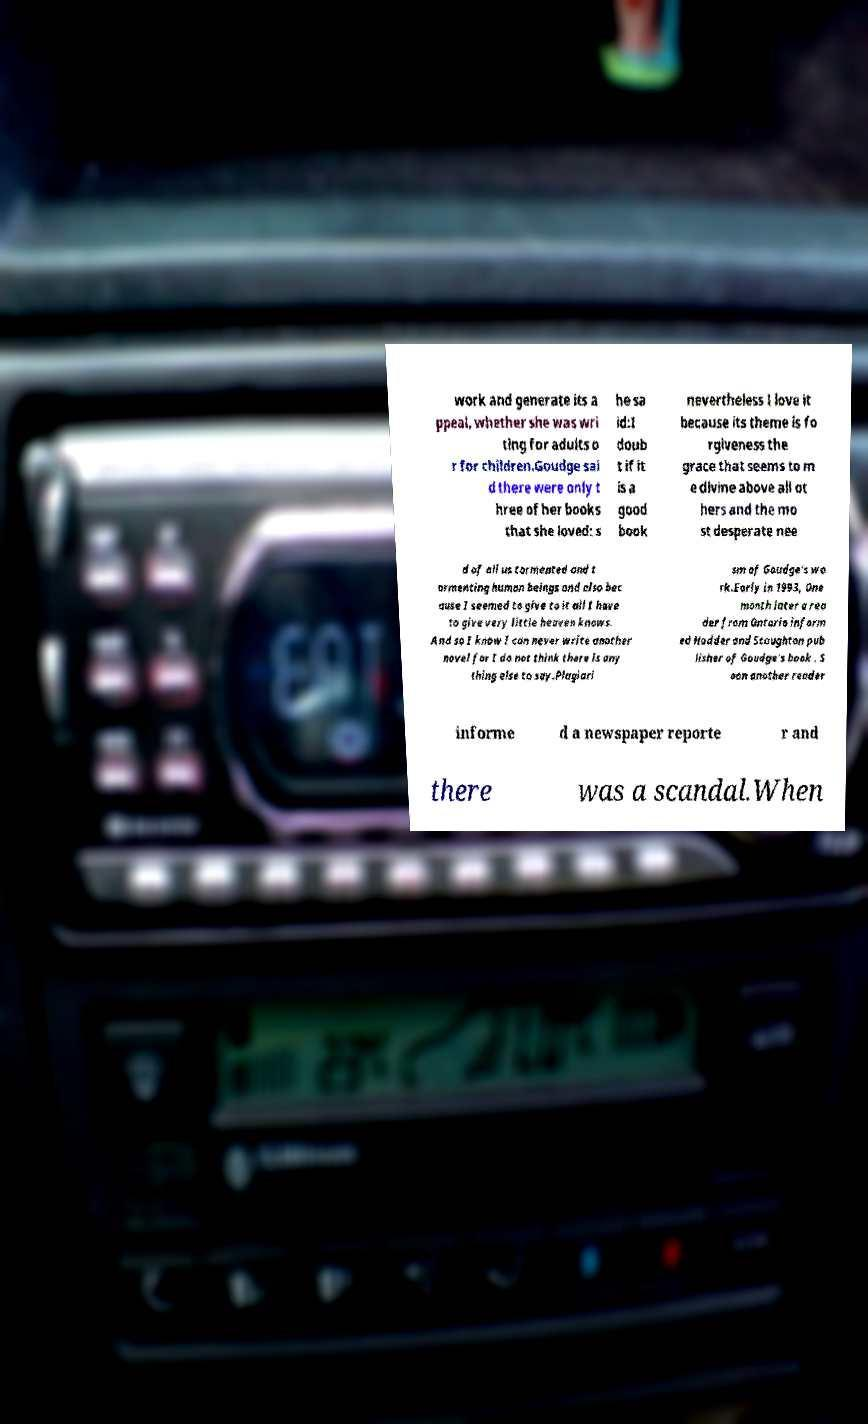Could you extract and type out the text from this image? work and generate its a ppeal, whether she was wri ting for adults o r for children.Goudge sai d there were only t hree of her books that she loved: s he sa id:I doub t if it is a good book nevertheless I love it because its theme is fo rgiveness the grace that seems to m e divine above all ot hers and the mo st desperate nee d of all us tormented and t ormenting human beings and also bec ause I seemed to give to it all I have to give very little heaven knows. And so I know I can never write another novel for I do not think there is any thing else to say.Plagiari sm of Goudge's wo rk.Early in 1993, One month later a rea der from Ontario inform ed Hodder and Stoughton pub lisher of Goudge's book . S oon another reader informe d a newspaper reporte r and there was a scandal.When 